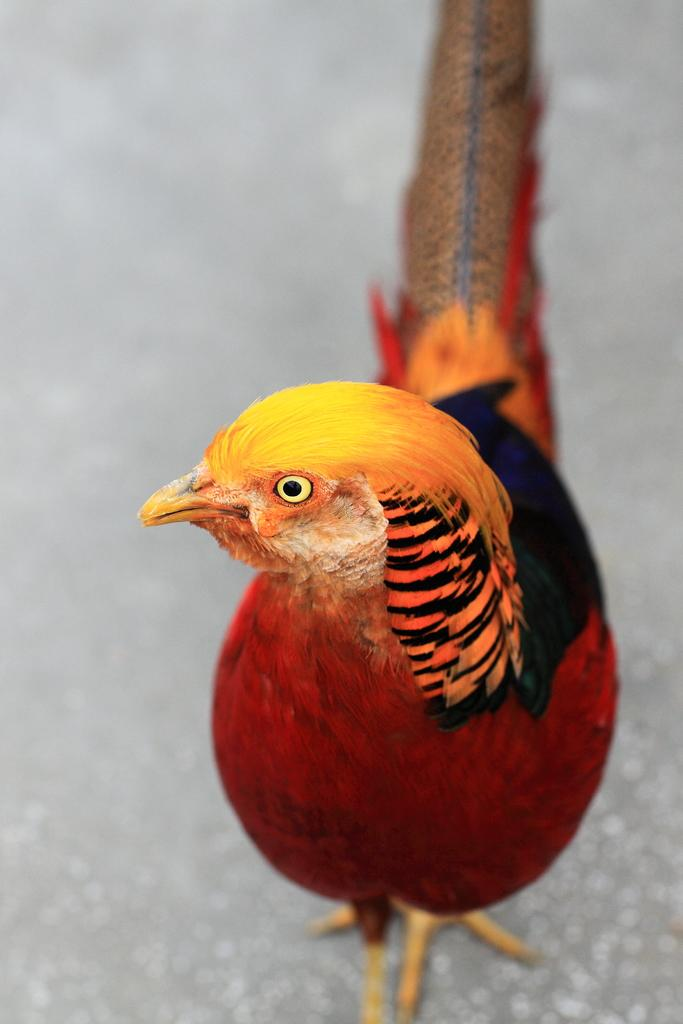What type of animal is in the image? There is a colorful hen in the image. Can you describe the appearance of the hen? The hen is colorful, but the specific colors are not mentioned in the facts. What might the hen be doing in the image? The facts do not provide information about the hen's actions, so we cannot definitively answer this question. What type of bear can be seen playing with the hen in the image? There is no bear present in the image; it only features a colorful hen. 